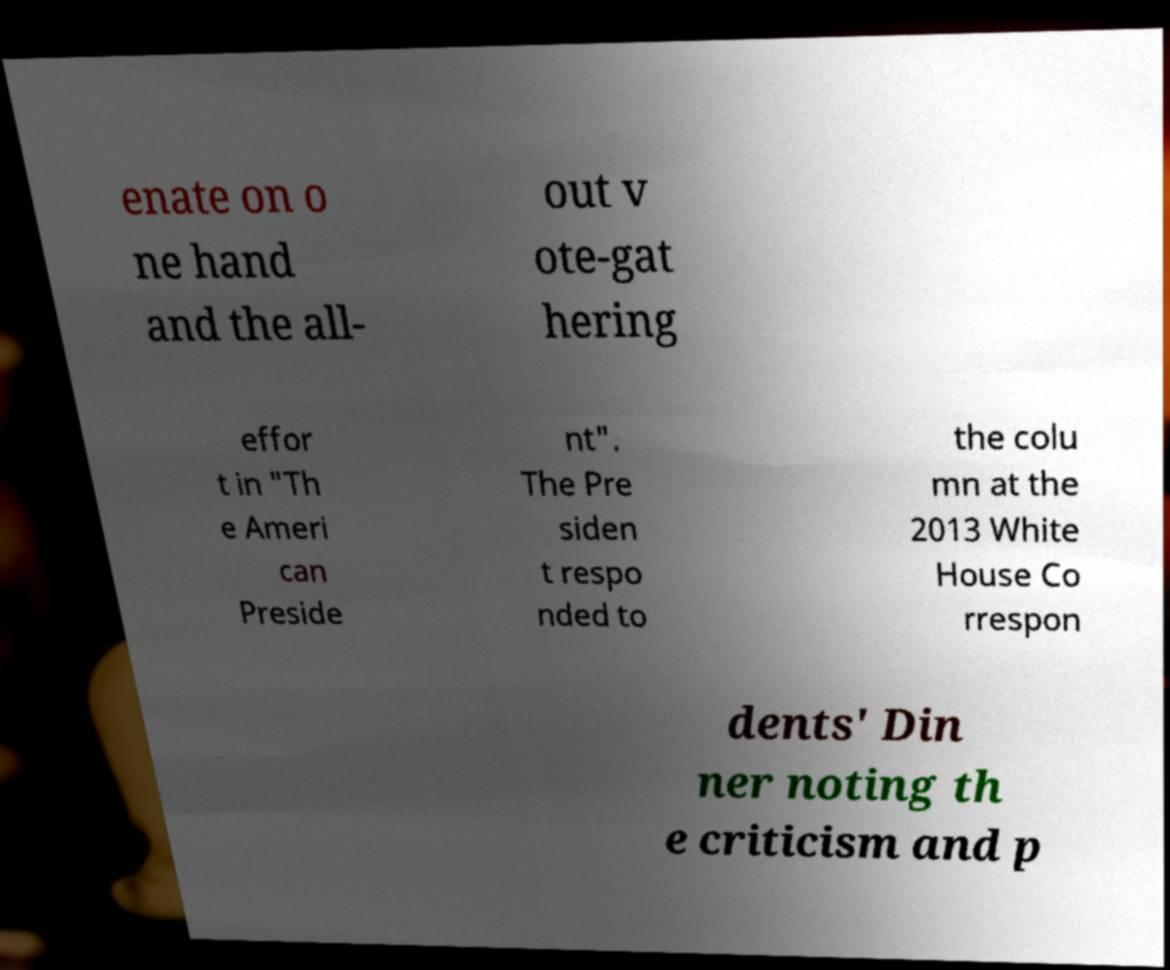There's text embedded in this image that I need extracted. Can you transcribe it verbatim? enate on o ne hand and the all- out v ote-gat hering effor t in "Th e Ameri can Preside nt". The Pre siden t respo nded to the colu mn at the 2013 White House Co rrespon dents' Din ner noting th e criticism and p 